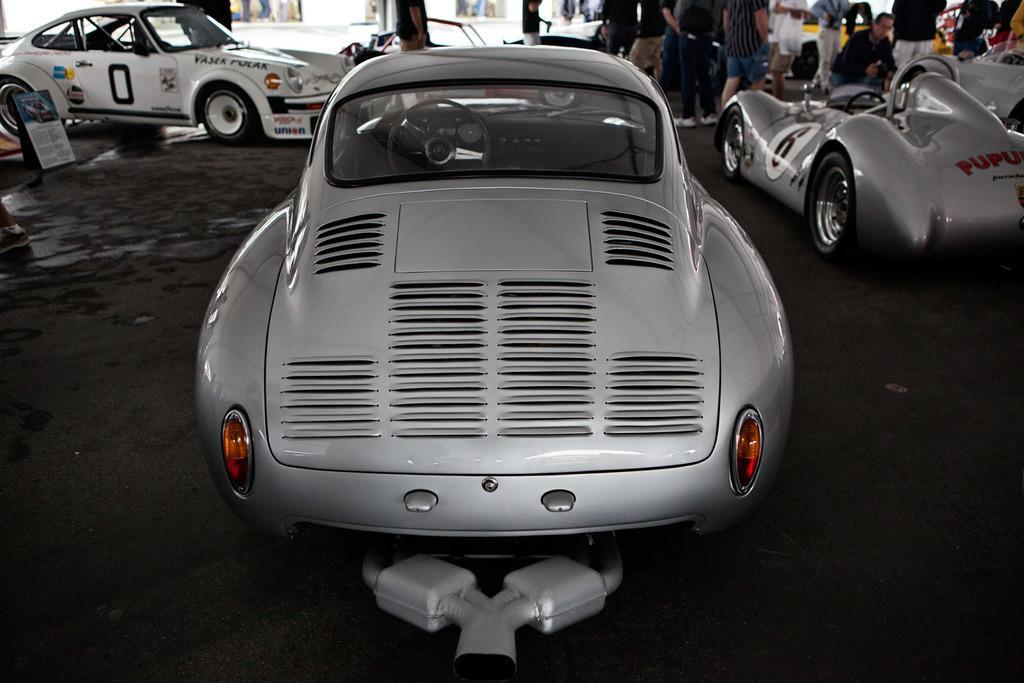How would you summarize this image in a sentence or two? In this image I can see few vehicles. Back Side I can see few people around. The vehicles are in different color. We can see a board. 